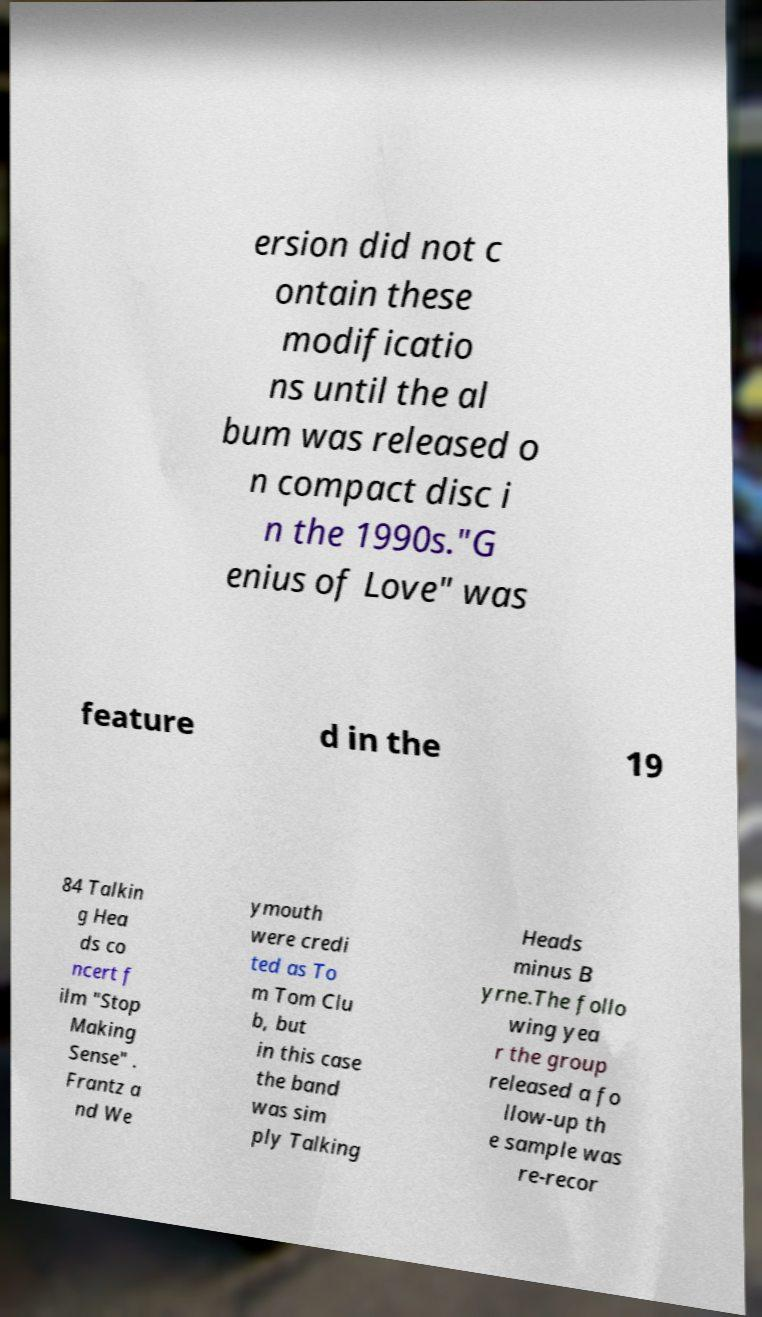Could you extract and type out the text from this image? ersion did not c ontain these modificatio ns until the al bum was released o n compact disc i n the 1990s."G enius of Love" was feature d in the 19 84 Talkin g Hea ds co ncert f ilm "Stop Making Sense" . Frantz a nd We ymouth were credi ted as To m Tom Clu b, but in this case the band was sim ply Talking Heads minus B yrne.The follo wing yea r the group released a fo llow-up th e sample was re-recor 